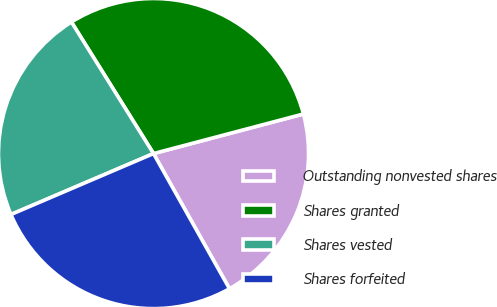Convert chart to OTSL. <chart><loc_0><loc_0><loc_500><loc_500><pie_chart><fcel>Outstanding nonvested shares<fcel>Shares granted<fcel>Shares vested<fcel>Shares forfeited<nl><fcel>20.96%<fcel>29.77%<fcel>22.55%<fcel>26.72%<nl></chart> 